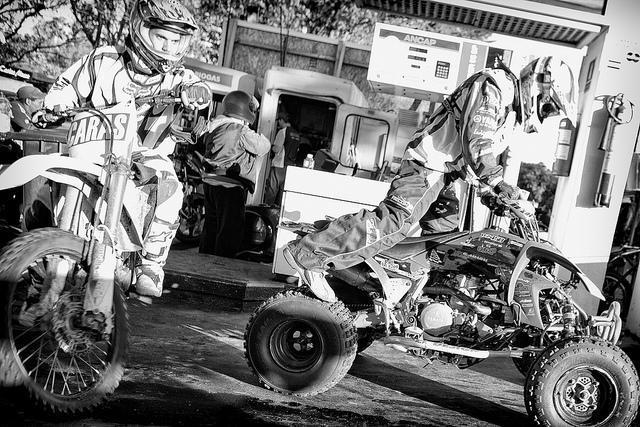How many people can be seen?
Give a very brief answer. 3. How many motorcycles can you see?
Give a very brief answer. 3. How many trees to the left of the giraffe are there?
Give a very brief answer. 0. 